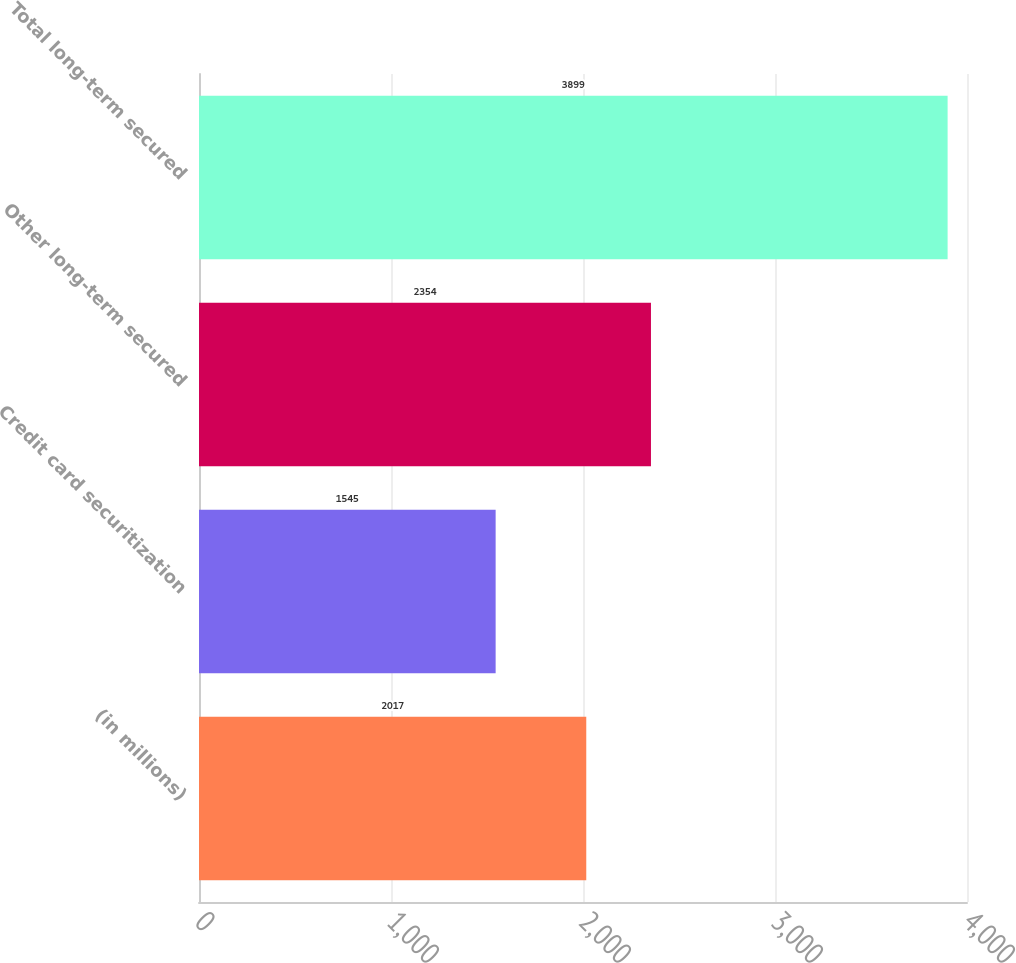<chart> <loc_0><loc_0><loc_500><loc_500><bar_chart><fcel>(in millions)<fcel>Credit card securitization<fcel>Other long-term secured<fcel>Total long-term secured<nl><fcel>2017<fcel>1545<fcel>2354<fcel>3899<nl></chart> 